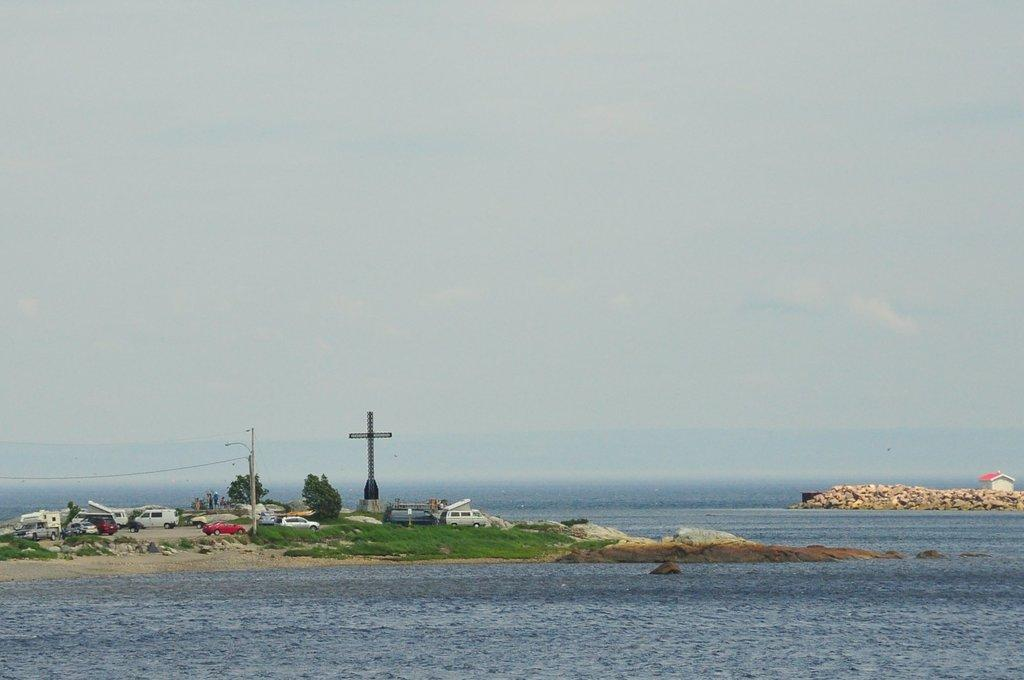What types of objects can be seen in the image? There are vehicles, trees, a pole, a tower, a shed, rocks, and water visible in the image. Can you describe the natural elements in the image? There are trees and rocks in the image, as well as water at the bottom. What structures are present in the image? There is a pole, a tower, and a shed in the image. What is visible at the top of the image? The sky is visible at the top of the image. What type of lace can be seen decorating the tower in the image? There is no lace present on the tower in the image. How many parcels are being delivered by the vehicles in the image? There is no indication of any parcels being delivered by the vehicles in the image. 